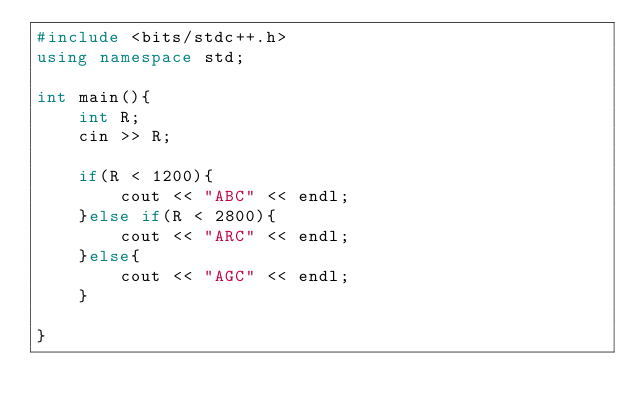<code> <loc_0><loc_0><loc_500><loc_500><_C++_>#include <bits/stdc++.h>
using namespace std;
 
int main(){
    int R;
    cin >> R;

    if(R < 1200){
        cout << "ABC" << endl;
    }else if(R < 2800){
        cout << "ARC" << endl;
    }else{
        cout << "AGC" << endl;
    }

}</code> 